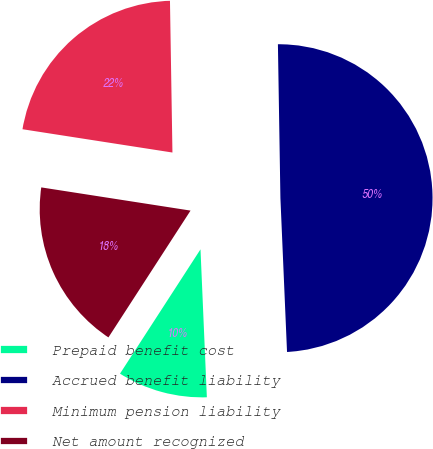<chart> <loc_0><loc_0><loc_500><loc_500><pie_chart><fcel>Prepaid benefit cost<fcel>Accrued benefit liability<fcel>Minimum pension liability<fcel>Net amount recognized<nl><fcel>9.83%<fcel>49.58%<fcel>22.29%<fcel>18.31%<nl></chart> 